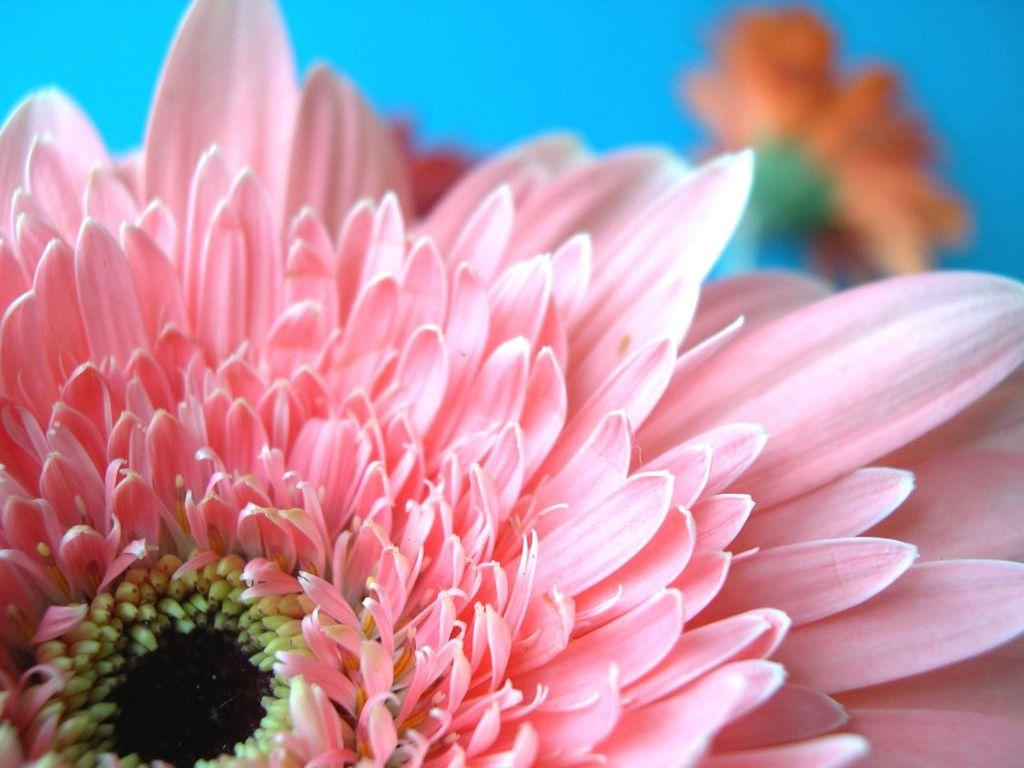What is the main subject of the image? There is a flower in the image. Can you describe the colors of the flower? The flower has yellow, black, and pink colors. Are there any other flowers visible in the image? Yes, there are more flowers visible in the background. What color is the background of the image? The background has a blue color. What type of doctor can be seen working at the desk in the image? There is no doctor or desk present in the image; it features a flower with a blue background. Can you tell me how many mountains are visible in the image? There are no mountains visible in the image; it features a flower with a blue background. 